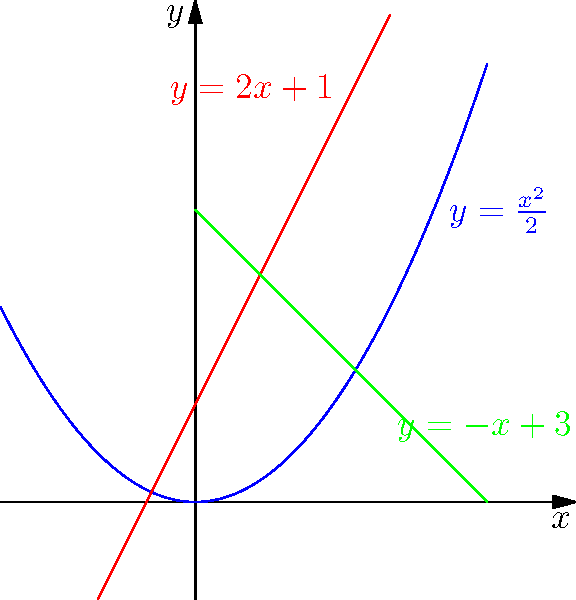In a world where privacy is increasingly valued, consider a geometric representation of data protection measures. The graph shows a parabola $y = \frac{x^2}{2}$ intersecting with two lines $y = 2x + 1$ and $y = -x + 3$. Calculate the area of the region bounded by these three curves, which represents the scope of personal information safeguarded from invasive media practices. To find the area, we'll follow these steps:

1) First, find the points of intersection:

   a) $\frac{x^2}{2} = 2x + 1$
      $x^2 - 4x - 2 = 0$
      $(x - 2)^2 = 6$
      $x = 2 \pm \sqrt{6}$
   
   b) $\frac{x^2}{2} = -x + 3$
      $x^2 + 2x - 6 = 0$
      $(x + 3)(x - 1) = 0$
      $x = 1$ or $x = -3$ (we'll use $x = 1$)

   c) $2x + 1 = -x + 3$
      $3x = 2$
      $x = \frac{2}{3}$

2) The region is bounded by $x = \frac{2}{3}$ and $x = 2 - \sqrt{6}$

3) Calculate the area:

   $A = \int_{\frac{2}{3}}^{2-\sqrt{6}} [(2x+1) - \frac{x^2}{2}] dx + \int_{2-\sqrt{6}}^1 [(-x+3) - \frac{x^2}{2}] dx$

4) Solve the integrals:

   $A = [x^2 + x - \frac{x^3}{6}]_{\frac{2}{3}}^{2-\sqrt{6}} + [-\frac{x^2}{2} + 3x - \frac{x^3}{6}]_{2-\sqrt{6}}^1$

5) Evaluate the limits and simplify:

   $A = [\frac{4}{9} - \frac{8}{27}] + [(\frac{1}{2} - \frac{1}{6}) - (\frac{14}{3} - 2\sqrt{6} - \frac{8-6\sqrt{6}}{3})]$

6) Final result:

   $A = \frac{4}{27} + \frac{1}{3} - \frac{14}{3} + 2\sqrt{6} + \frac{8-6\sqrt{6}}{3} = \frac{2\sqrt{6}}{3} - \frac{13}{9}$
Answer: $\frac{2\sqrt{6}}{3} - \frac{13}{9}$ square units 